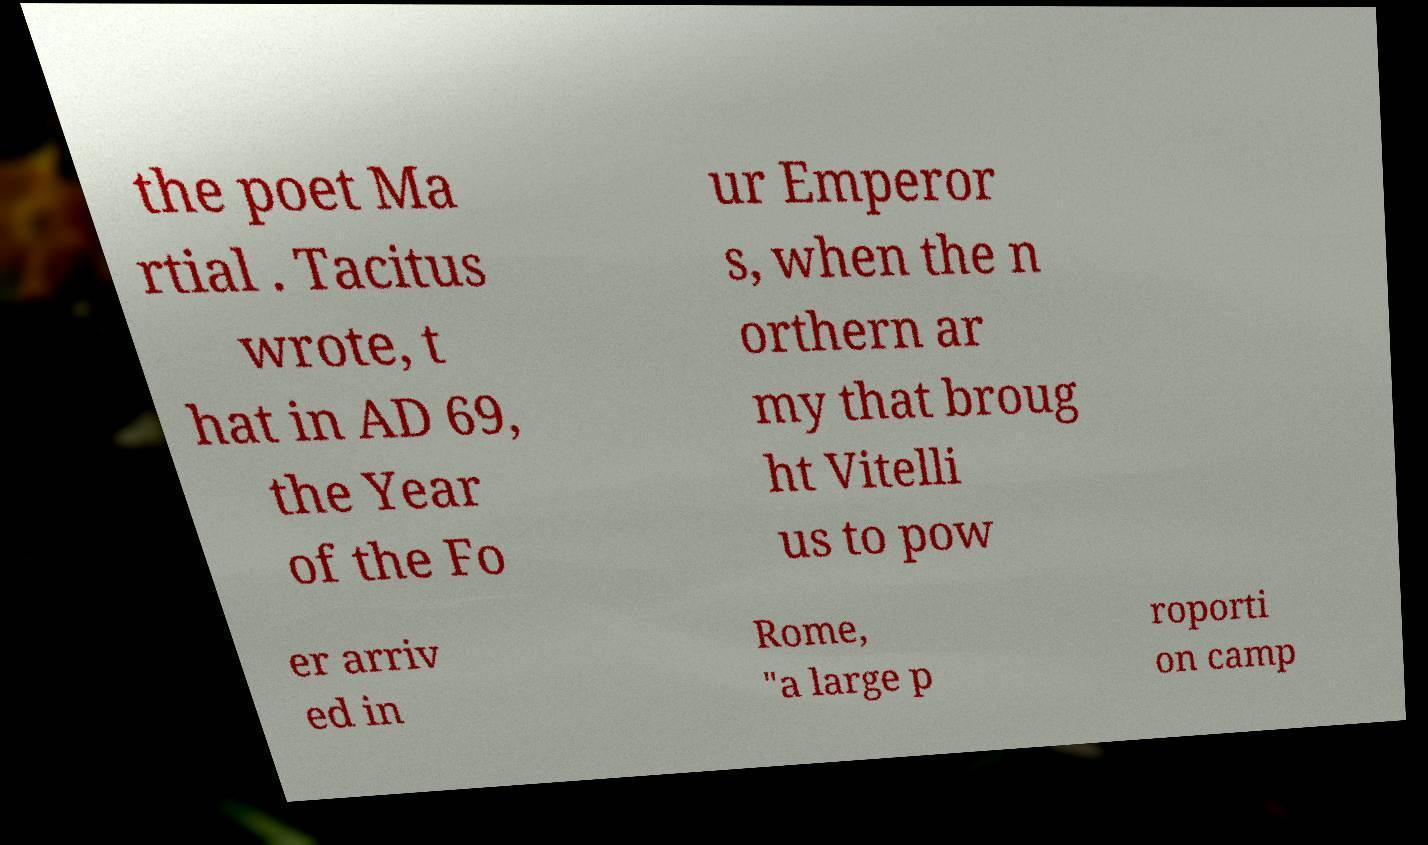What messages or text are displayed in this image? I need them in a readable, typed format. the poet Ma rtial . Tacitus wrote, t hat in AD 69, the Year of the Fo ur Emperor s, when the n orthern ar my that broug ht Vitelli us to pow er arriv ed in Rome, "a large p roporti on camp 